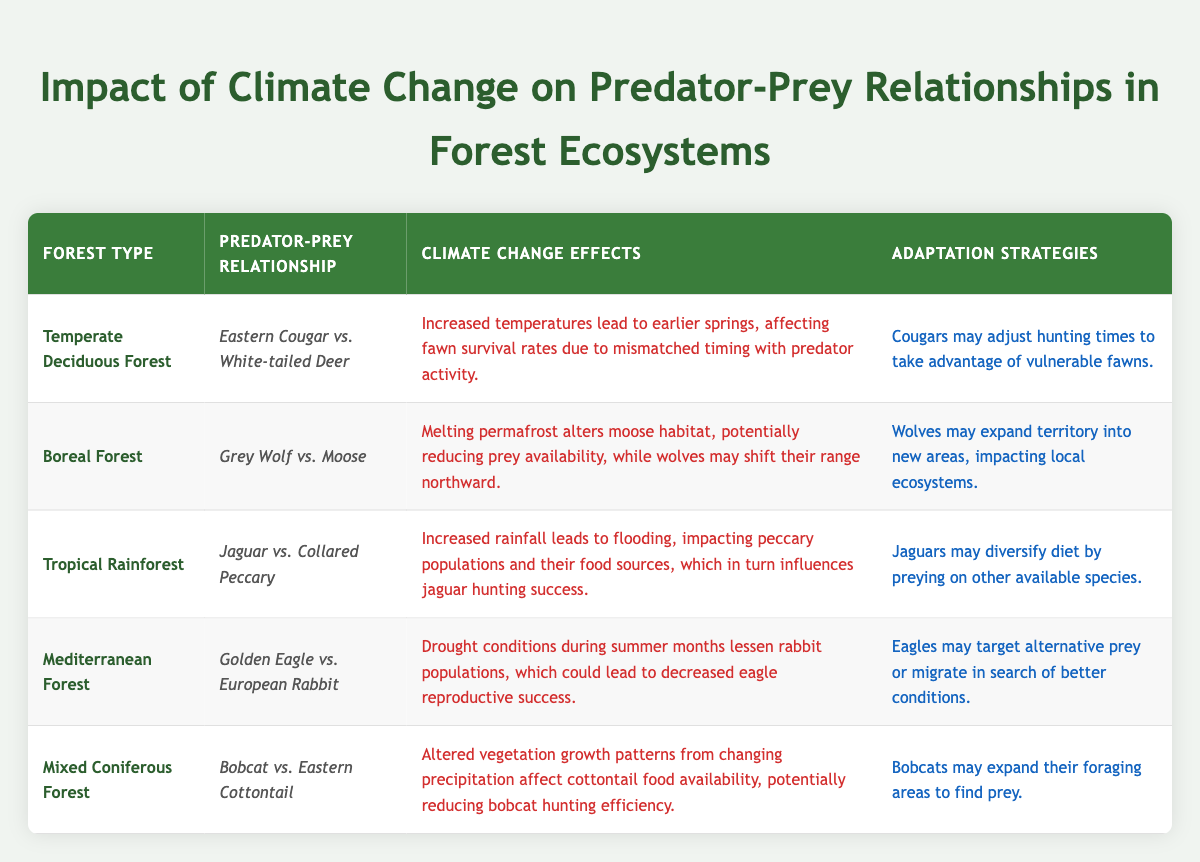What predator-prey relationship is affected in the Temperate Deciduous Forest? The Temperate Deciduous Forest features the Eastern Cougar as the predator and the White-tailed Deer as the prey. This information is directly retrievable from the table under the respective forest type.
Answer: Eastern Cougar vs. White-tailed Deer Which predator's adaptation strategy involves targeting alternative prey? The predator involved in targeting alternative prey is the Golden Eagle, as mentioned in the adaptation strategies for the Mediterranean Forest section of the table.
Answer: Golden Eagle Is the climate change effect on the Grey Wolf's prey primarily due to melting permafrost? Yes, the table indicates that melting permafrost alters moose habitat, directly impacting prey availability for the Grey Wolf.
Answer: Yes How many forest types experience drought conditions affecting prey populations? There are two forest types mentioned in the table that experience drought conditions: the Mediterranean Forest and the Tropical Rainforest. Summing this, we find two.
Answer: 2 What is the prey species for Jaguars in Tropical Rainforests and what climate effect influences their hunting success? The prey species for Jaguars in Tropical Rainforests is the Collared Peccary. The climate effect that influences their hunting success is increased rainfall leading to flooding and affecting peccary populations.
Answer: Collared Peccary; increased rainfall What are the adaptation strategies for both Bobcat and Eastern Cottontail under changing conditions? The Bobcat may expand their foraging areas to find prey in changing conditions. The Eastern Cottontail's food availability could be affected, but the focus is primarily on the Bobcat's adaptability in response. Thus, the answer centers on the Bobcat's strategy.
Answer: Expand foraging areas In how many cases do climate change effects negatively impact reproductive success of predators? The table indicates that the climate change effects negatively impact the reproductive success of the Golden Eagle in the Mediterranean Forest. There are no other clear mentions of reduced reproductive success in other predator species listed, making it one.
Answer: 1 What common climate change effect do both the Eastern Cougar and Golden Eagle face in their respective ecosystems? Both the Eastern Cougar and Golden Eagle face timing disruptions due to climate change effects; for the Cougar, it's related to earlier springs affecting fawn survival, and for the Eagle, drought conditions lessen rabbit populations. This highlights shifts in prey availability and impacts on hunting conditions.
Answer: Disruption in prey availability and timing What adaptations might Jaguars make in response to flooding affecting peccary populations? Jaguars may diversify their diet by preying on other available species in response to the flooding that affects peccary populations, as stated in the adaptation strategies row of the Tropical Rainforest section.
Answer: Diversify diet by preying on other species 